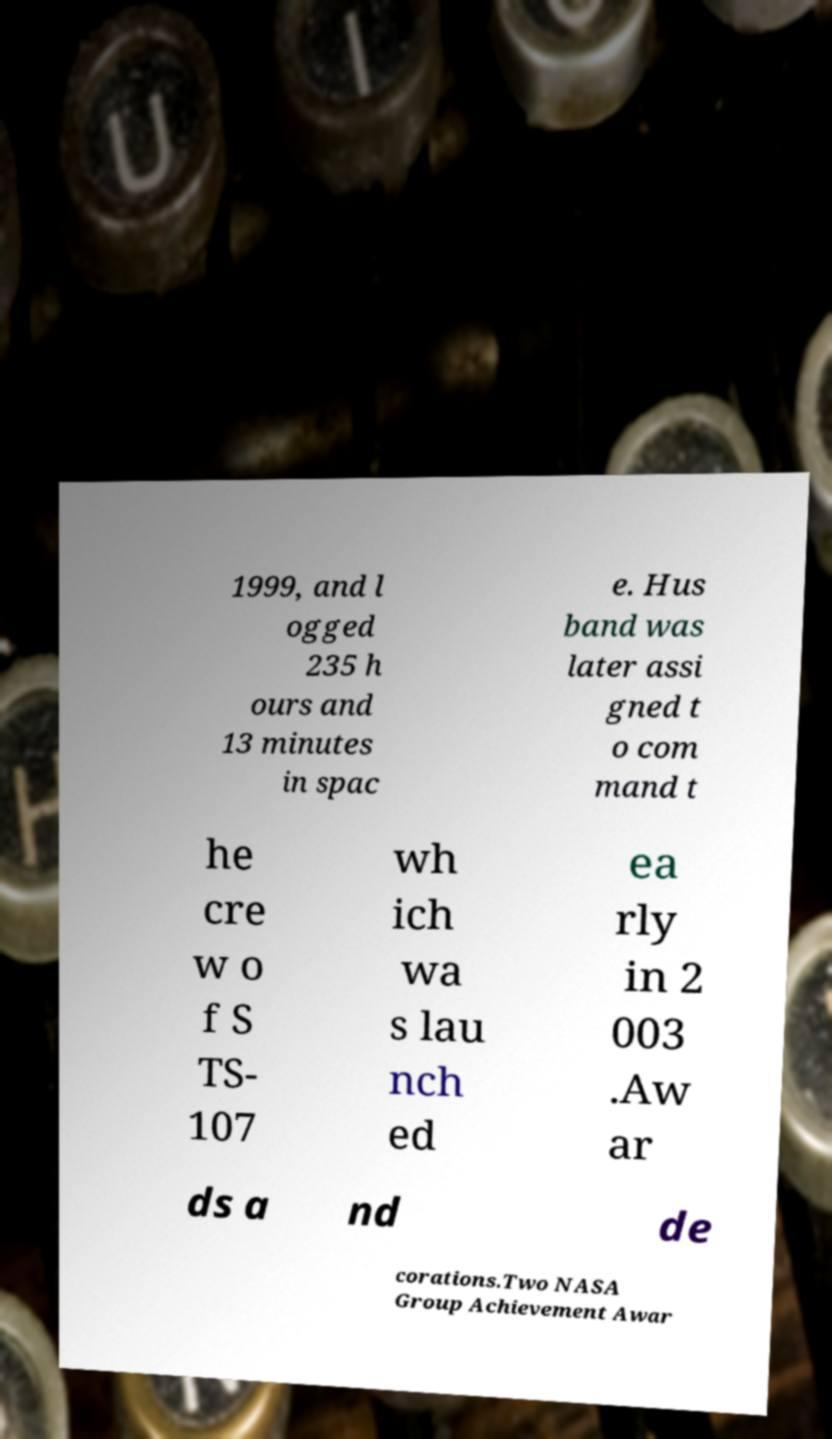Can you accurately transcribe the text from the provided image for me? 1999, and l ogged 235 h ours and 13 minutes in spac e. Hus band was later assi gned t o com mand t he cre w o f S TS- 107 wh ich wa s lau nch ed ea rly in 2 003 .Aw ar ds a nd de corations.Two NASA Group Achievement Awar 